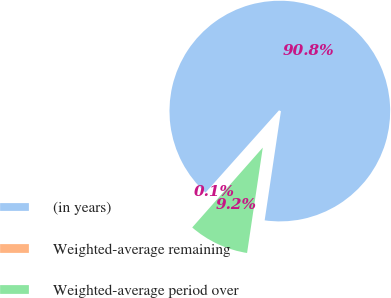Convert chart. <chart><loc_0><loc_0><loc_500><loc_500><pie_chart><fcel>(in years)<fcel>Weighted-average remaining<fcel>Weighted-average period over<nl><fcel>90.75%<fcel>0.09%<fcel>9.16%<nl></chart> 